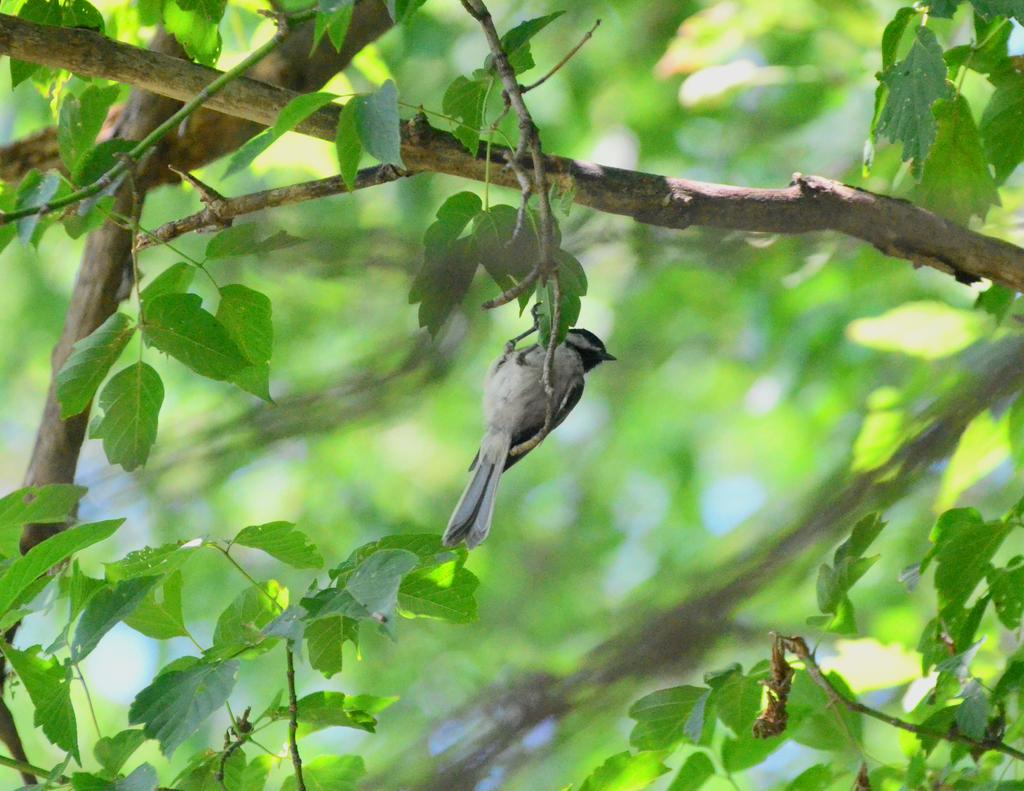What type of animal can be seen in the image? There is a bird in the image. Where is the bird located? The bird is on a branch of a tree. What can be seen in the tree besides the bird? There are green leaves in the image. How would you describe the background of the image? The background of the image is blurred. What type of beam is holding up the bridge in the image? There is no bridge or beam present in the image; it features a bird on a tree branch with green leaves and a blurred background. 